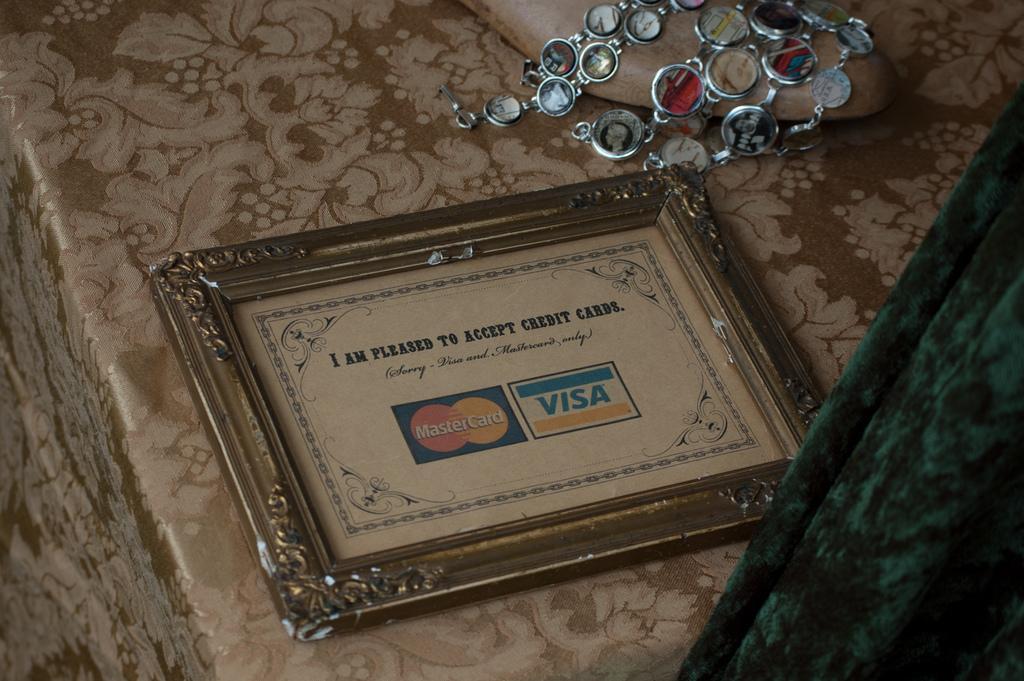Could you give a brief overview of what you see in this image? We can see frame, ornament and footwear on the platform. On the right side of the image we can see green object. 